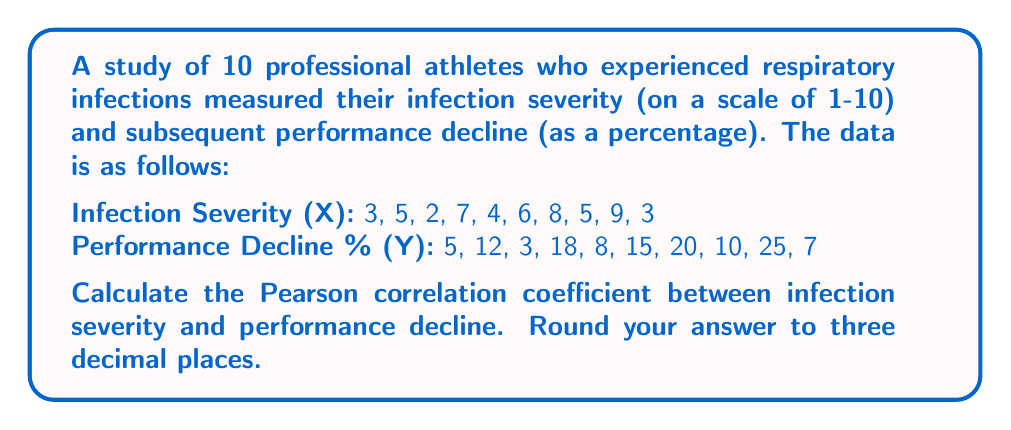Teach me how to tackle this problem. To calculate the Pearson correlation coefficient (r), we'll use the formula:

$$ r = \frac{n\sum xy - \sum x \sum y}{\sqrt{[n\sum x^2 - (\sum x)^2][n\sum y^2 - (\sum y)^2]}} $$

Step 1: Calculate the sums and squared sums:
$\sum x = 52$
$\sum y = 123$
$\sum x^2 = 324$
$\sum y^2 = 2,039$
$\sum xy = 805$
$n = 10$

Step 2: Apply the formula:

$$ r = \frac{10(805) - (52)(123)}{\sqrt{[10(324) - 52^2][10(2039) - 123^2]}} $$

Step 3: Simplify:

$$ r = \frac{8050 - 6396}{\sqrt{(3240 - 2704)(20390 - 15129)}} $$

$$ r = \frac{1654}{\sqrt{(536)(5261)}} $$

$$ r = \frac{1654}{\sqrt{2819896}} $$

$$ r = \frac{1654}{1679.254} $$

$$ r = 0.9849825 $$

Step 4: Round to three decimal places:

$r = 0.985$
Answer: 0.985 